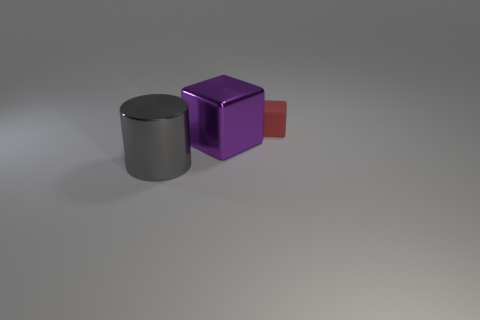Add 2 tiny purple matte spheres. How many objects exist? 5 Subtract all purple blocks. How many blocks are left? 1 Subtract all cylinders. How many objects are left? 2 Add 2 large shiny cylinders. How many large shiny cylinders are left? 3 Add 2 tiny matte things. How many tiny matte things exist? 3 Subtract 1 gray cylinders. How many objects are left? 2 Subtract all green cubes. Subtract all blue spheres. How many cubes are left? 2 Subtract all gray things. Subtract all large purple shiny cubes. How many objects are left? 1 